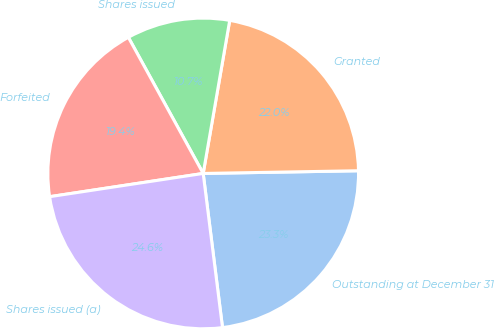Convert chart. <chart><loc_0><loc_0><loc_500><loc_500><pie_chart><fcel>Outstanding at December 31<fcel>Granted<fcel>Shares issued<fcel>Forfeited<fcel>Shares issued (a)<nl><fcel>23.29%<fcel>21.99%<fcel>10.73%<fcel>19.39%<fcel>24.59%<nl></chart> 